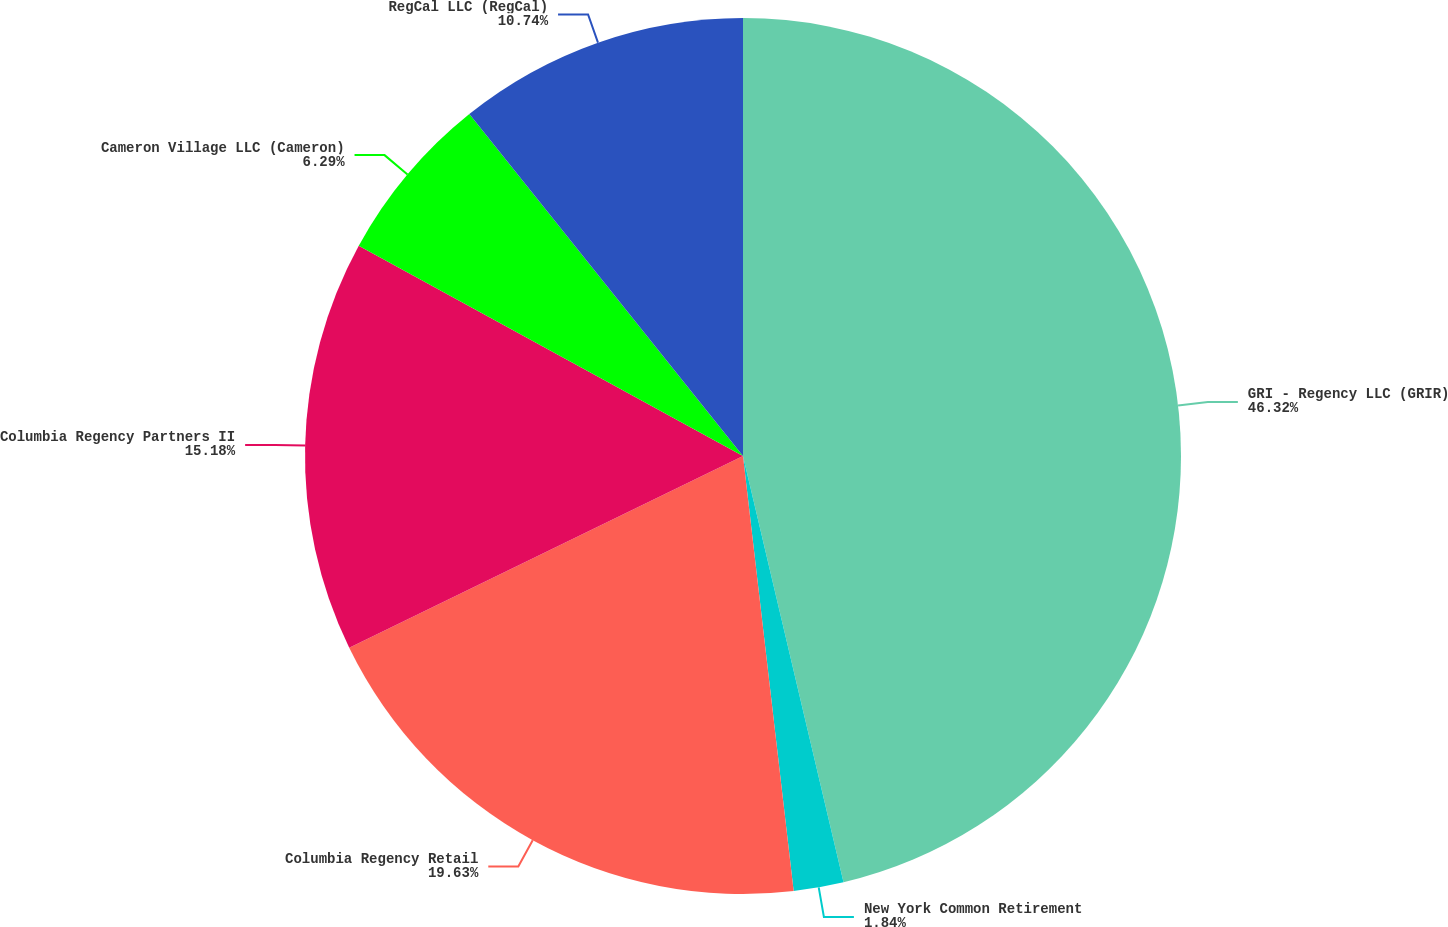Convert chart. <chart><loc_0><loc_0><loc_500><loc_500><pie_chart><fcel>GRI - Regency LLC (GRIR)<fcel>New York Common Retirement<fcel>Columbia Regency Retail<fcel>Columbia Regency Partners II<fcel>Cameron Village LLC (Cameron)<fcel>RegCal LLC (RegCal)<nl><fcel>46.31%<fcel>1.84%<fcel>19.63%<fcel>15.18%<fcel>6.29%<fcel>10.74%<nl></chart> 